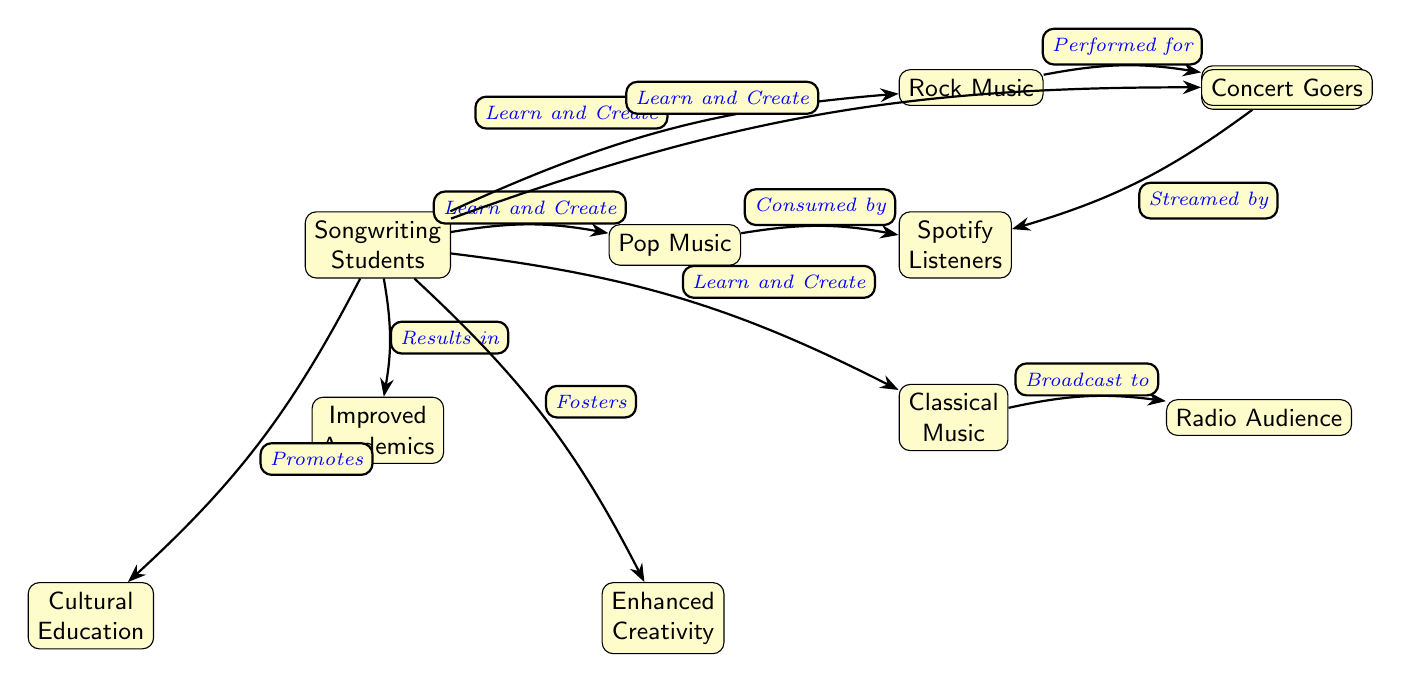What type of music is consumed by Spotify listeners? The diagram indicates that Pop Music and Hip-Hop/Rap are streamed by Spotify listeners according to the edges leading to the corresponding nodes.
Answer: Pop Music, Hip-Hop/Rap How many types of music genres are listed in the diagram? The diagram shows four music genres: Pop Music, Rock Music, Classical Music, and Hip-Hop/Rap. Counting these gives a total of four.
Answer: 4 What is the relationship between students and improved academics? The arrow from "Songwriting Students" to "Improved Academics" labeled "Results in" indicates a direct relationship where the students' activities result in improved academic performance.
Answer: Results in Who are the concert goers performing for? The diagram indicates that the Rock Music node is directed to "Concert Goers" with the label "Performed for," showing that concert goers are associated with live performances of rock music.
Answer: Concert Goers What does songwriting foster in students according to the diagram? The diagram connects "Songwriting Students" to "Enhanced Creativity" by the label "Fosters," which shows that songwriting activities encourage creativity in students.
Answer: Enhanced Creativity Which audience is accustomed to classical music according to the diagram? The arrow from "Classical Music" to "Radio Audience," labeled "Broadcast to," suggests that classical music is primarily related to the radio audience that listens to it.
Answer: Radio Audience What prompts cultural education from the students? The connection in the diagram labeled "Promotes" specifies that cultural education arises from the activities of "Songwriting Students," indicating that their engagement in songwriting promotes cultural understanding.
Answer: Promotes Which node is directly related to rock music? The node "Concert Goers" is directly connected to "Rock Music" with an edge labeled "Performed for," showing a direct relationship between the two.
Answer: Concert Goers How many edges connect students to different types of music? From the diagram, the "Songwriting Students" node connects to four different music genres: Pop, Rock, Classical, and Hip-Hop/Rap, resulting in four edges.
Answer: 4 